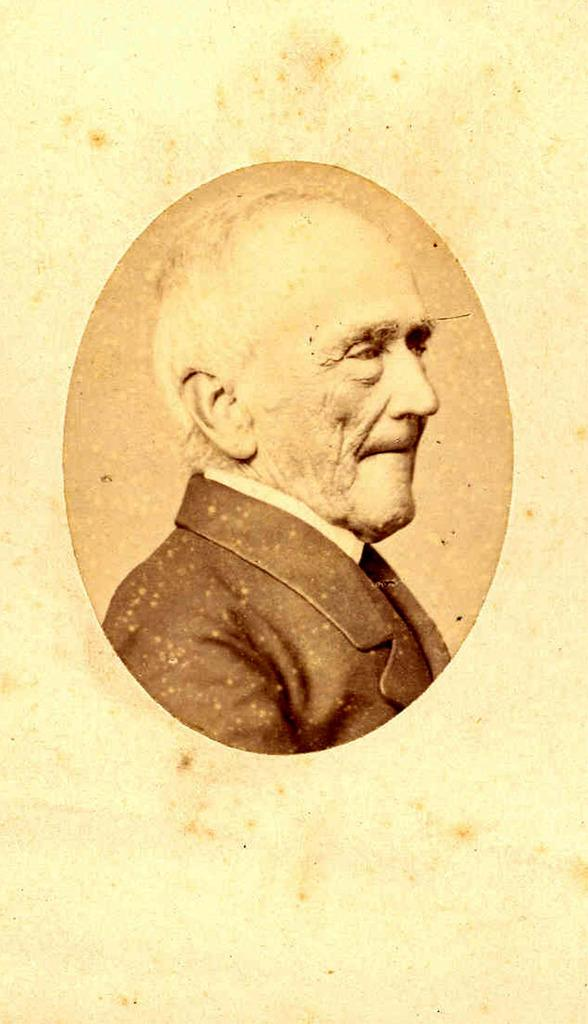What is the main subject of the image? There is a picture of a person in the image. Where is the picture of the person located in the image? The picture of the person is in the middle of the image. How many letters are visible in the picture of the person? There is no mention of letters in the image, as it only features a picture of a person. What type of ducks can be seen swimming in the background of the image? There is no reference to ducks in the image; it only contains a picture of a person. 